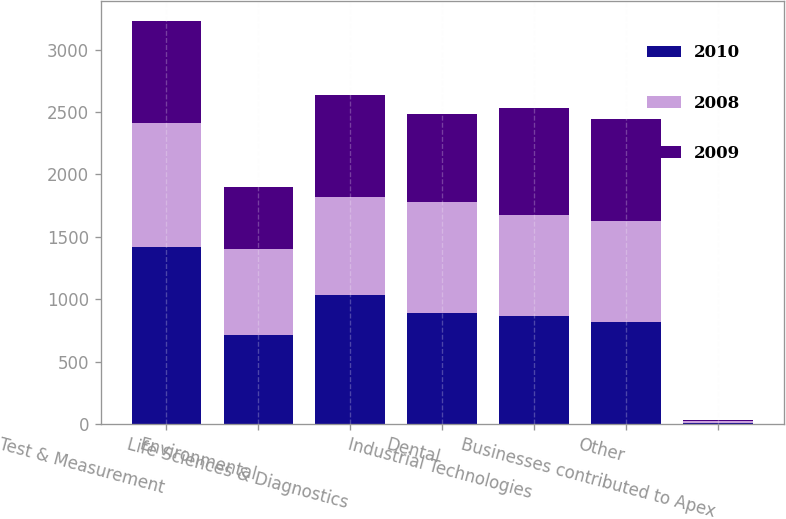<chart> <loc_0><loc_0><loc_500><loc_500><stacked_bar_chart><ecel><fcel>Test & Measurement<fcel>Environmental<fcel>Life Sciences & Diagnostics<fcel>Dental<fcel>Industrial Technologies<fcel>Other<fcel>Businesses contributed to Apex<nl><fcel>2010<fcel>1416.6<fcel>709.5<fcel>1031.3<fcel>885.7<fcel>866.2<fcel>813.6<fcel>6.2<nl><fcel>2008<fcel>995.4<fcel>696<fcel>787.1<fcel>894.5<fcel>808.9<fcel>813.6<fcel>13.8<nl><fcel>2009<fcel>818.5<fcel>493.2<fcel>818.3<fcel>703.4<fcel>856.2<fcel>813.6<fcel>14<nl></chart> 